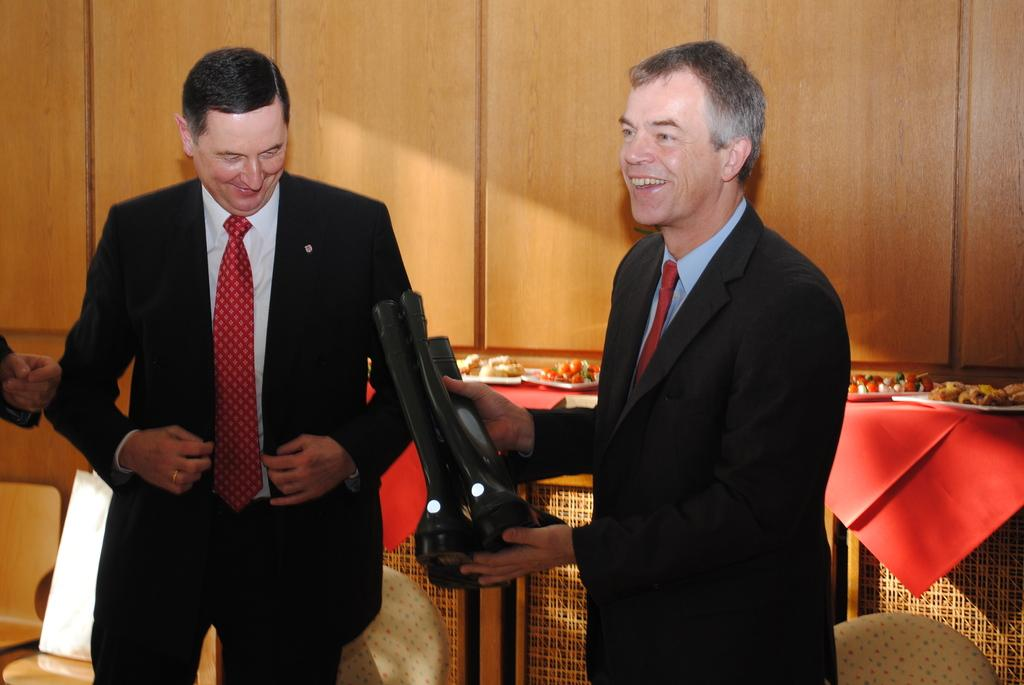How many people are present in the image? There are two people standing in the image. What is the man holding in the image? The man is holding a pair of boots. What can be seen behind the people in the image? There are food items visible behind the people. What type of wall is visible in the background of the image? There is a wooden wall in the background of the image. What type of flower is growing on the edge of the wooden wall in the image? There are no flowers visible in the image, and the wooden wall does not have an edge. 